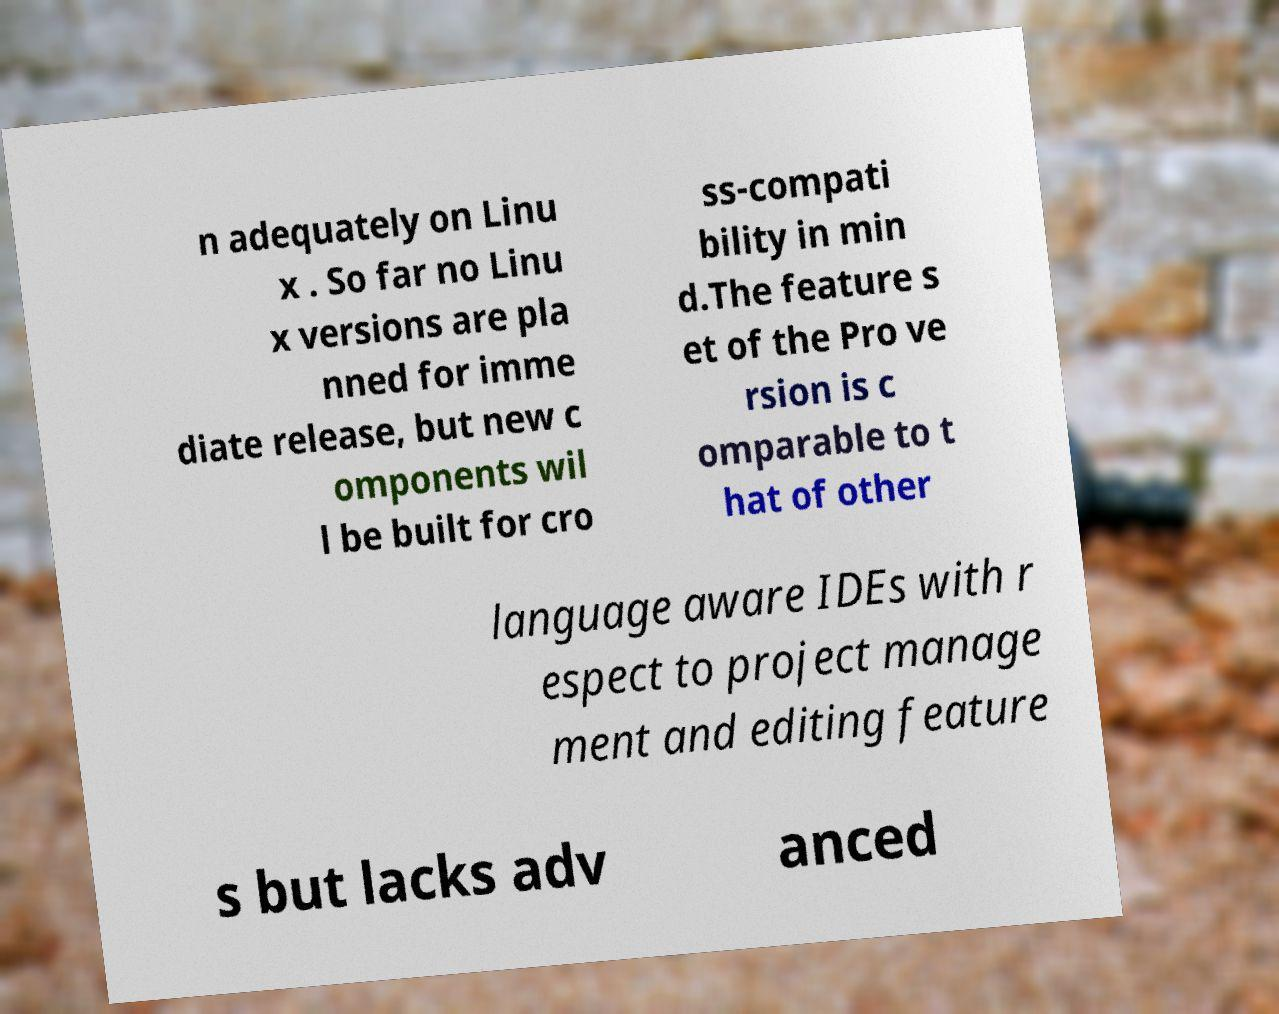Can you accurately transcribe the text from the provided image for me? n adequately on Linu x . So far no Linu x versions are pla nned for imme diate release, but new c omponents wil l be built for cro ss-compati bility in min d.The feature s et of the Pro ve rsion is c omparable to t hat of other language aware IDEs with r espect to project manage ment and editing feature s but lacks adv anced 